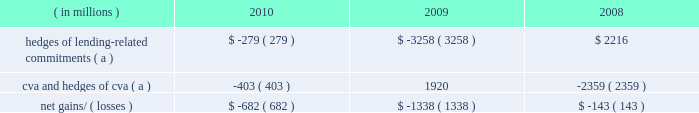Management 2019s discussion and analysis 128 jpmorgan chase & co./2010 annual report year ended december 31 .
( a ) these hedges do not qualify for hedge accounting under u.s .
Gaap .
Lending-related commitments jpmorgan chase uses lending-related financial instruments , such as commitments and guarantees , to meet the financing needs of its customers .
The contractual amount of these financial instruments represents the maximum possible credit risk should the counterpar- ties draw down on these commitments or the firm fulfills its obliga- tion under these guarantees , and should the counterparties subsequently fail to perform according to the terms of these con- tracts .
Wholesale lending-related commitments were $ 346.1 billion at december 31 , 2010 , compared with $ 347.2 billion at december 31 , 2009 .
The decrease reflected the january 1 , 2010 , adoption of accounting guidance related to vies .
Excluding the effect of the accounting guidance , lending-related commitments would have increased by $ 16.6 billion .
In the firm 2019s view , the total contractual amount of these wholesale lending-related commitments is not representative of the firm 2019s actual credit risk exposure or funding requirements .
In determining the amount of credit risk exposure the firm has to wholesale lend- ing-related commitments , which is used as the basis for allocating credit risk capital to these commitments , the firm has established a 201cloan-equivalent 201d amount for each commitment ; this amount represents the portion of the unused commitment or other contin- gent exposure that is expected , based on average portfolio histori- cal experience , to become drawn upon in an event of a default by an obligor .
The loan-equivalent amounts of the firm 2019s lending- related commitments were $ 189.9 billion and $ 179.8 billion as of december 31 , 2010 and 2009 , respectively .
Country exposure the firm 2019s wholesale portfolio includes country risk exposures to both developed and emerging markets .
The firm seeks to diversify its country exposures , including its credit-related lending , trading and investment activities , whether cross-border or locally funded .
Country exposure under the firm 2019s internal risk management ap- proach is reported based on the country where the assets of the obligor , counterparty or guarantor are located .
Exposure amounts , including resale agreements , are adjusted for collateral and for credit enhancements ( e.g. , guarantees and letters of credit ) pro- vided by third parties ; outstandings supported by a guarantor located outside the country or backed by collateral held outside the country are assigned to the country of the enhancement provider .
In addition , the effect of credit derivative hedges and other short credit or equity trading positions are taken into consideration .
Total exposure measures include activity with both government and private-sector entities in a country .
The firm also reports country exposure for regulatory purposes following ffiec guidelines , which are different from the firm 2019s internal risk management approach for measuring country expo- sure .
For additional information on the ffiec exposures , see cross- border outstandings on page 314 of this annual report .
Several european countries , including greece , portugal , spain , italy and ireland , have been subject to credit deterioration due to weak- nesses in their economic and fiscal situations .
The firm is closely monitoring its exposures to these five countries .
Aggregate net exposures to these five countries as measured under the firm 2019s internal approach was less than $ 15.0 billion at december 31 , 2010 , with no country representing a majority of the exposure .
Sovereign exposure in all five countries represented less than half the aggregate net exposure .
The firm currently believes its exposure to these five countries is modest relative to the firm 2019s overall risk expo- sures and is manageable given the size and types of exposures to each of the countries and the diversification of the aggregate expo- sure .
The firm continues to conduct business and support client activity in these countries and , therefore , the firm 2019s aggregate net exposures may vary over time .
In addition , the net exposures may be impacted by changes in market conditions , and the effects of interest rates and credit spreads on market valuations .
As part of its ongoing country risk management process , the firm monitors exposure to emerging market countries , and utilizes country stress tests to measure and manage the risk of extreme loss associated with a sovereign crisis .
There is no common definition of emerging markets , but the firm generally includes in its definition those countries whose sovereign debt ratings are equivalent to 201ca+ 201d or lower .
The table below presents the firm 2019s exposure to its top 10 emerging markets countries based on its internal measure- ment approach .
The selection of countries is based solely on the firm 2019s largest total exposures by country and does not represent its view of any actual or potentially adverse credit conditions. .
What was the annual decline in wholesale lending-related commitments in 2010? 
Computations: ((346.1 - 347.2) / 347.2)
Answer: -0.00317. 